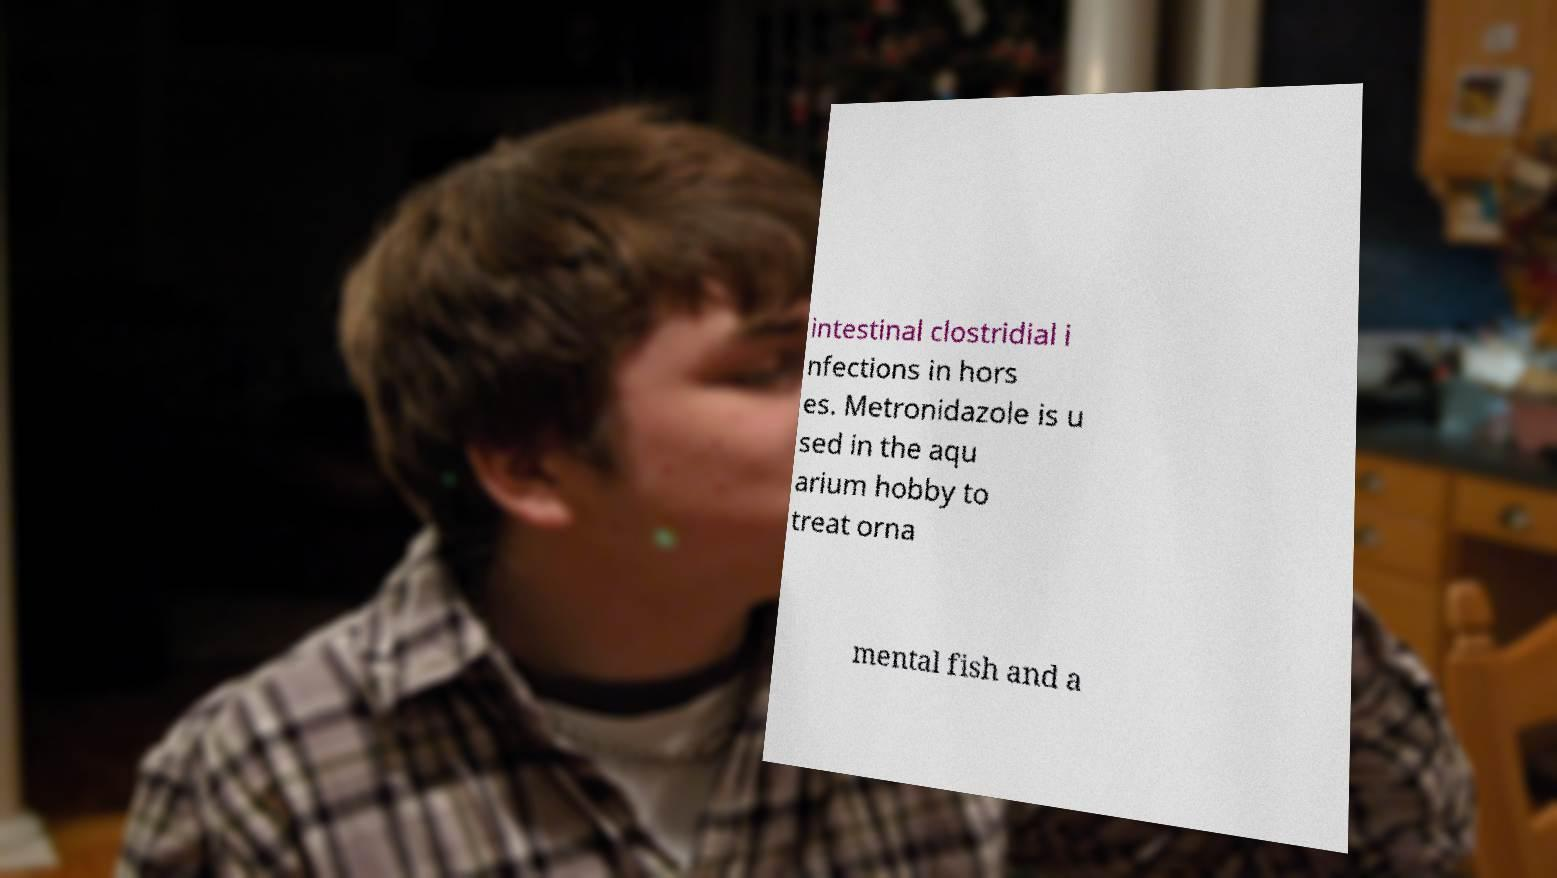Could you extract and type out the text from this image? intestinal clostridial i nfections in hors es. Metronidazole is u sed in the aqu arium hobby to treat orna mental fish and a 